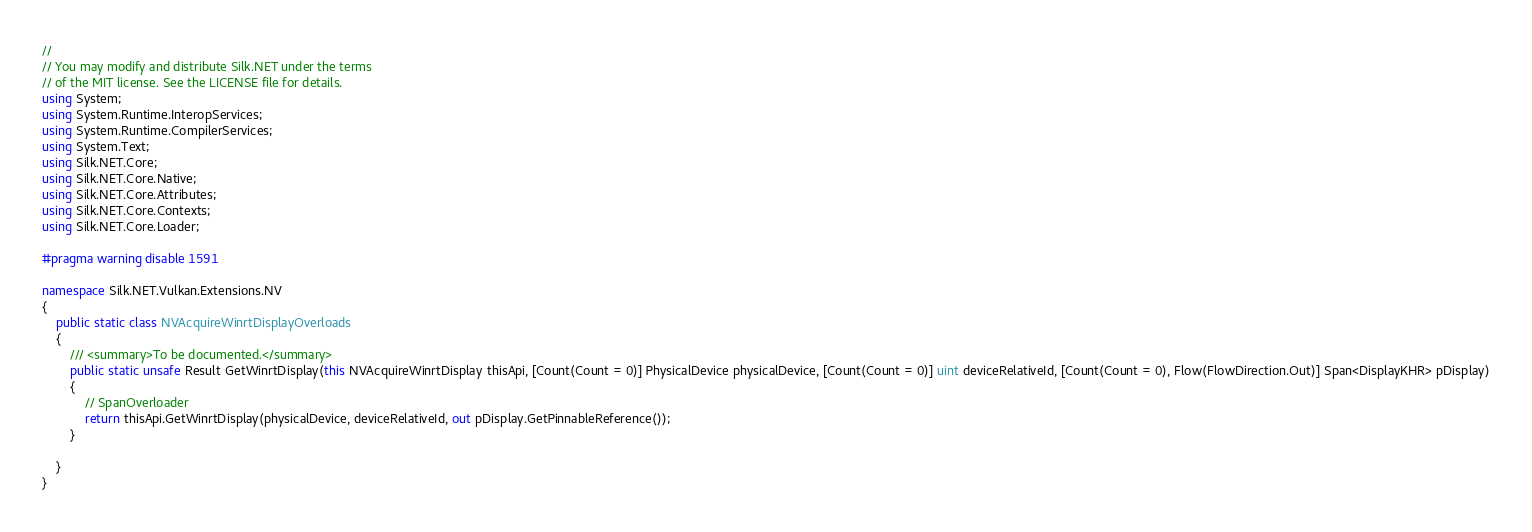<code> <loc_0><loc_0><loc_500><loc_500><_C#_>// 
// You may modify and distribute Silk.NET under the terms
// of the MIT license. See the LICENSE file for details.
using System;
using System.Runtime.InteropServices;
using System.Runtime.CompilerServices;
using System.Text;
using Silk.NET.Core;
using Silk.NET.Core.Native;
using Silk.NET.Core.Attributes;
using Silk.NET.Core.Contexts;
using Silk.NET.Core.Loader;

#pragma warning disable 1591

namespace Silk.NET.Vulkan.Extensions.NV
{
    public static class NVAcquireWinrtDisplayOverloads
    {
        /// <summary>To be documented.</summary>
        public static unsafe Result GetWinrtDisplay(this NVAcquireWinrtDisplay thisApi, [Count(Count = 0)] PhysicalDevice physicalDevice, [Count(Count = 0)] uint deviceRelativeId, [Count(Count = 0), Flow(FlowDirection.Out)] Span<DisplayKHR> pDisplay)
        {
            // SpanOverloader
            return thisApi.GetWinrtDisplay(physicalDevice, deviceRelativeId, out pDisplay.GetPinnableReference());
        }

    }
}

</code> 